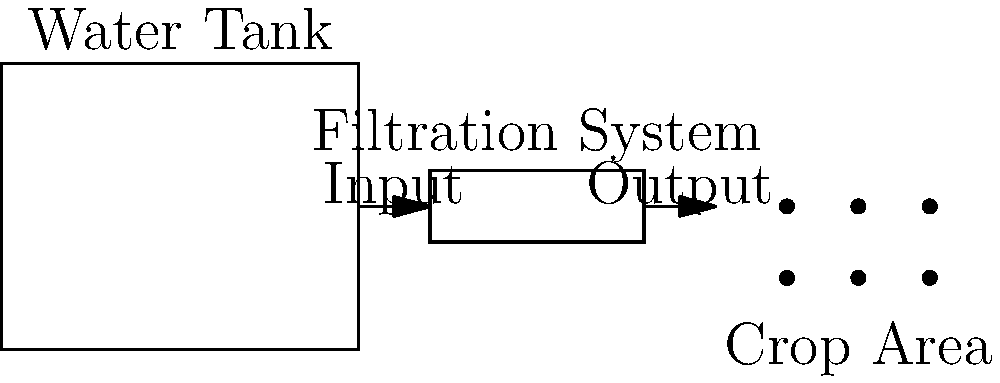You're designing a small-scale water filtration system for your medicinal crop watering. The system needs to filter 500 gallons of water per day. If the filtration rate is 25 gallons per hour, how many hours per day should the system operate to meet the daily requirement? Let's approach this step-by-step:

1. Understand the given information:
   - Daily water requirement: 500 gallons
   - Filtration rate: 25 gallons per hour

2. Set up the equation:
   Let $x$ be the number of hours the system should operate.
   
   $$\text{Filtration rate} \times \text{Hours of operation} = \text{Daily requirement}$$
   $$25 \text{ gallons/hour} \times x \text{ hours} = 500 \text{ gallons}$$

3. Solve the equation:
   $$25x = 500$$
   $$x = \frac{500}{25}$$
   $$x = 20$$

Therefore, the filtration system should operate for 20 hours per day to meet the daily requirement of 500 gallons.
Answer: 20 hours 